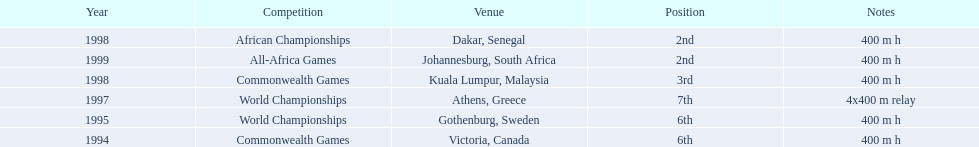What races did ken harden run? 400 m h, 400 m h, 4x400 m relay, 400 m h, 400 m h, 400 m h. Which race did ken harden run in 1997? 4x400 m relay. 